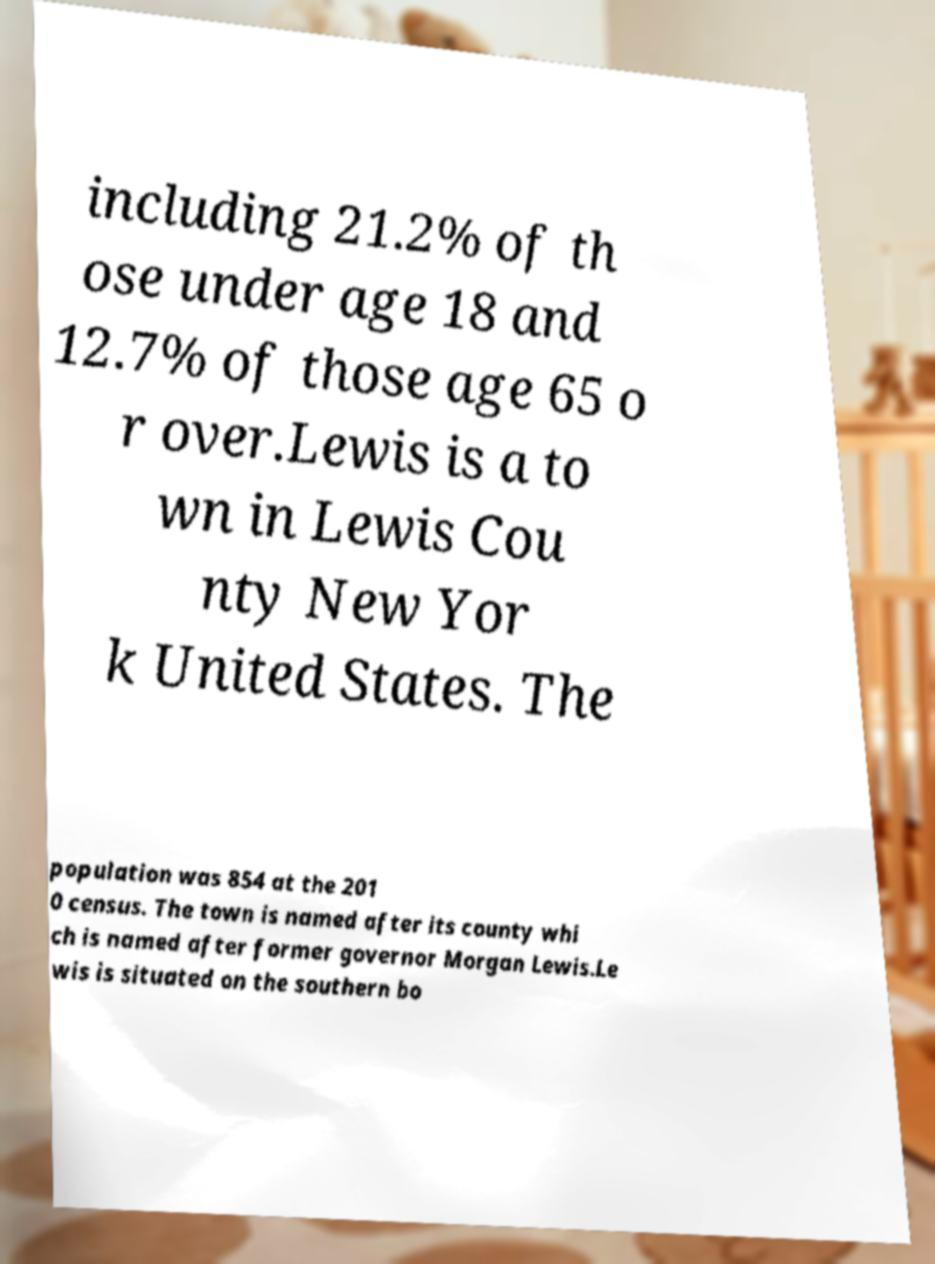Please identify and transcribe the text found in this image. including 21.2% of th ose under age 18 and 12.7% of those age 65 o r over.Lewis is a to wn in Lewis Cou nty New Yor k United States. The population was 854 at the 201 0 census. The town is named after its county whi ch is named after former governor Morgan Lewis.Le wis is situated on the southern bo 